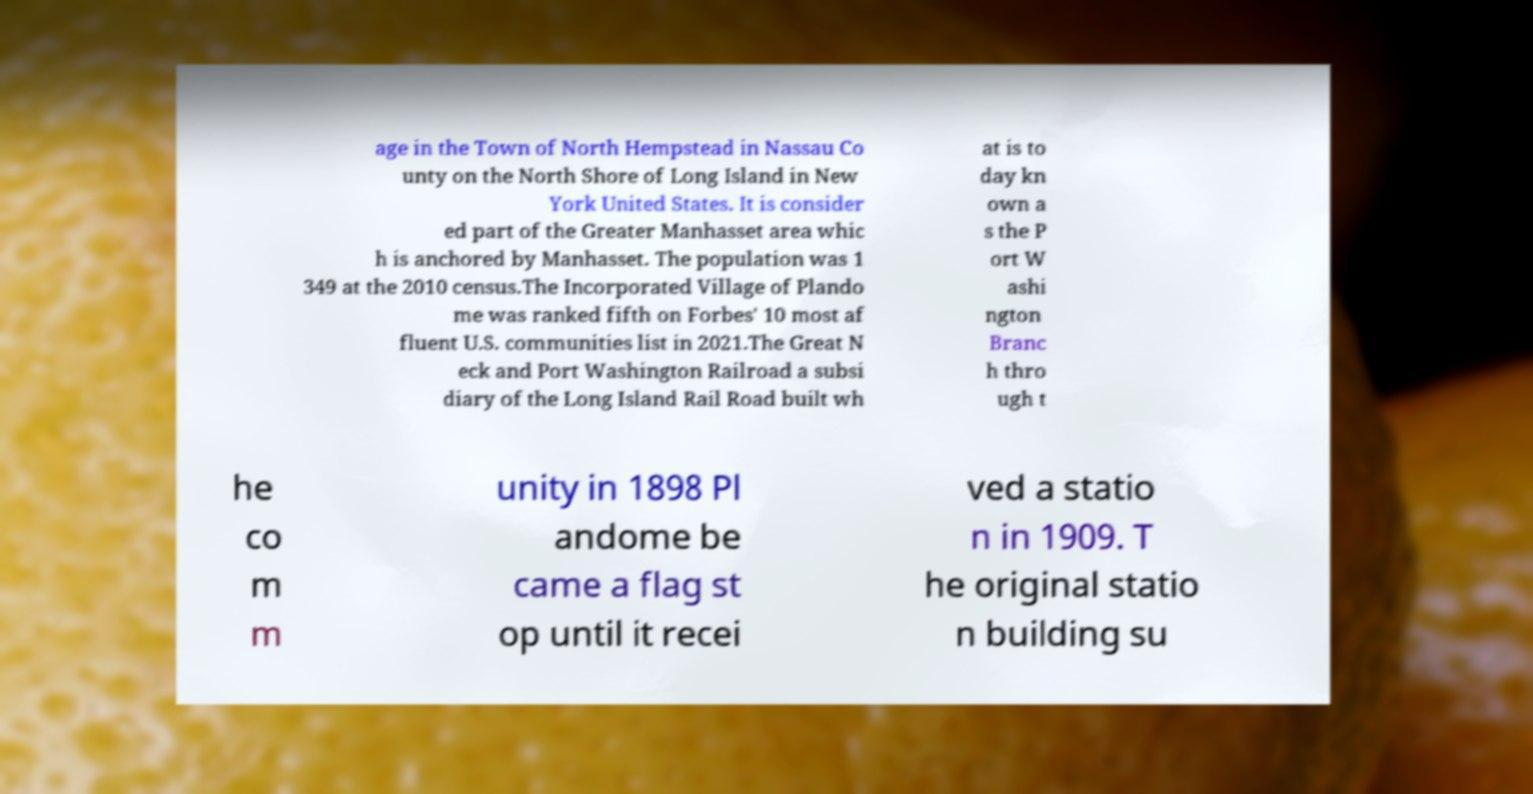Please read and relay the text visible in this image. What does it say? age in the Town of North Hempstead in Nassau Co unty on the North Shore of Long Island in New York United States. It is consider ed part of the Greater Manhasset area whic h is anchored by Manhasset. The population was 1 349 at the 2010 census.The Incorporated Village of Plando me was ranked fifth on Forbes' 10 most af fluent U.S. communities list in 2021.The Great N eck and Port Washington Railroad a subsi diary of the Long Island Rail Road built wh at is to day kn own a s the P ort W ashi ngton Branc h thro ugh t he co m m unity in 1898 Pl andome be came a flag st op until it recei ved a statio n in 1909. T he original statio n building su 